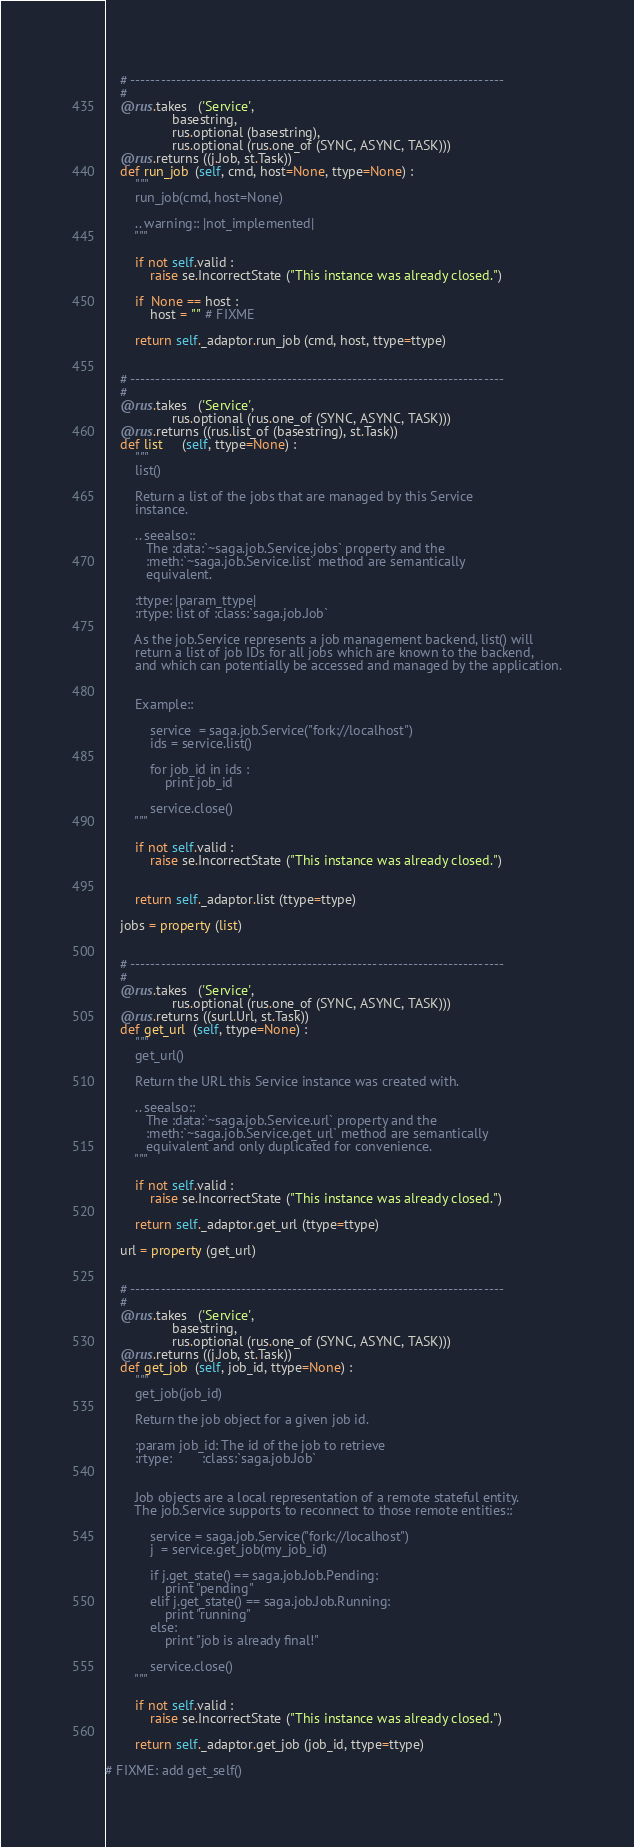Convert code to text. <code><loc_0><loc_0><loc_500><loc_500><_Python_>
    # --------------------------------------------------------------------------
    #
    @rus.takes   ('Service', 
                  basestring,
                  rus.optional (basestring),
                  rus.optional (rus.one_of (SYNC, ASYNC, TASK)))
    @rus.returns ((j.Job, st.Task))
    def run_job  (self, cmd, host=None, ttype=None) :
        """ 
        run_job(cmd, host=None)
        
        .. warning:: |not_implemented|
        """

        if not self.valid :
            raise se.IncorrectState ("This instance was already closed.")

        if  None == host :
            host = "" # FIXME

        return self._adaptor.run_job (cmd, host, ttype=ttype)


    # --------------------------------------------------------------------------
    #
    @rus.takes   ('Service',
                  rus.optional (rus.one_of (SYNC, ASYNC, TASK)))
    @rus.returns ((rus.list_of (basestring), st.Task))
    def list     (self, ttype=None) :
        """ 
        list()

        Return a list of the jobs that are managed by this Service 
        instance. 

        .. seealso:: 
           The :data:`~saga.job.Service.jobs` property and the
           :meth:`~saga.job.Service.list` method are semantically 
           equivalent.

        :ttype: |param_ttype|
        :rtype: list of :class:`saga.job.Job`

        As the job.Service represents a job management backend, list() will
        return a list of job IDs for all jobs which are known to the backend,
        and which can potentially be accessed and managed by the application.


        Example::

            service  = saga.job.Service("fork://localhost")
            ids = service.list()

            for job_id in ids :
                print job_id

            service.close()
        """

        if not self.valid :
            raise se.IncorrectState ("This instance was already closed.")


        return self._adaptor.list (ttype=ttype)

    jobs = property (list)    


    # --------------------------------------------------------------------------
    #
    @rus.takes   ('Service',
                  rus.optional (rus.one_of (SYNC, ASYNC, TASK)))
    @rus.returns ((surl.Url, st.Task))
    def get_url  (self, ttype=None) :
        """ 
        get_url()

        Return the URL this Service instance was created with.

        .. seealso:: 
           The :data:`~saga.job.Service.url` property and the
           :meth:`~saga.job.Service.get_url` method are semantically 
           equivalent and only duplicated for convenience.
        """

        if not self.valid :
            raise se.IncorrectState ("This instance was already closed.")

        return self._adaptor.get_url (ttype=ttype)

    url = property (get_url) 


    # --------------------------------------------------------------------------
    #
    @rus.takes   ('Service',
                  basestring,
                  rus.optional (rus.one_of (SYNC, ASYNC, TASK)))
    @rus.returns ((j.Job, st.Task))
    def get_job  (self, job_id, ttype=None) :
        """ 
        get_job(job_id)

        Return the job object for a given job id.

        :param job_id: The id of the job to retrieve
        :rtype:        :class:`saga.job.Job`


        Job objects are a local representation of a remote stateful entity.
        The job.Service supports to reconnect to those remote entities::

            service = saga.job.Service("fork://localhost")
            j  = service.get_job(my_job_id)

            if j.get_state() == saga.job.Job.Pending: 
                print "pending"
            elif j.get_state() == saga.job.Job.Running:
                print "running"
            else: 
                print "job is already final!"

            service.close()
        """

        if not self.valid :
            raise se.IncorrectState ("This instance was already closed.")

        return self._adaptor.get_job (job_id, ttype=ttype)

# FIXME: add get_self()

</code> 